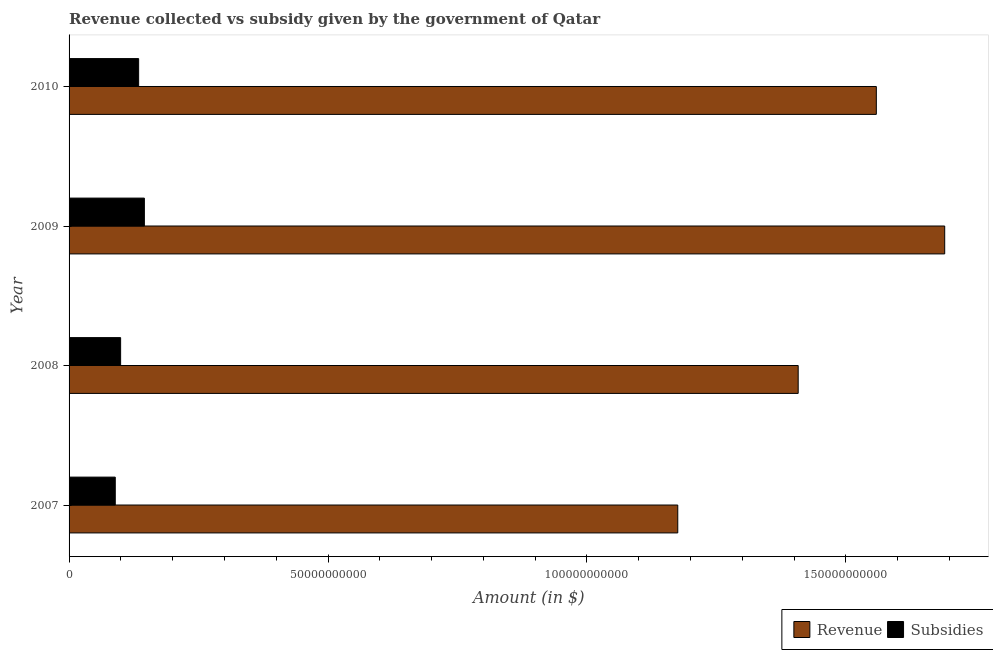How many groups of bars are there?
Your response must be concise. 4. How many bars are there on the 4th tick from the top?
Make the answer very short. 2. What is the label of the 3rd group of bars from the top?
Make the answer very short. 2008. In how many cases, is the number of bars for a given year not equal to the number of legend labels?
Your answer should be very brief. 0. What is the amount of subsidies given in 2010?
Your answer should be very brief. 1.34e+1. Across all years, what is the maximum amount of subsidies given?
Your response must be concise. 1.45e+1. Across all years, what is the minimum amount of revenue collected?
Keep it short and to the point. 1.18e+11. In which year was the amount of revenue collected maximum?
Provide a succinct answer. 2009. What is the total amount of subsidies given in the graph?
Your answer should be very brief. 4.68e+1. What is the difference between the amount of revenue collected in 2007 and that in 2010?
Your answer should be very brief. -3.83e+1. What is the difference between the amount of subsidies given in 2008 and the amount of revenue collected in 2009?
Give a very brief answer. -1.59e+11. What is the average amount of revenue collected per year?
Offer a very short reply. 1.46e+11. In the year 2009, what is the difference between the amount of revenue collected and amount of subsidies given?
Ensure brevity in your answer.  1.55e+11. What is the ratio of the amount of revenue collected in 2007 to that in 2008?
Provide a short and direct response. 0.83. What is the difference between the highest and the second highest amount of subsidies given?
Make the answer very short. 1.11e+09. What is the difference between the highest and the lowest amount of revenue collected?
Ensure brevity in your answer.  5.15e+1. In how many years, is the amount of revenue collected greater than the average amount of revenue collected taken over all years?
Give a very brief answer. 2. What does the 1st bar from the top in 2010 represents?
Ensure brevity in your answer.  Subsidies. What does the 2nd bar from the bottom in 2007 represents?
Make the answer very short. Subsidies. How many years are there in the graph?
Your answer should be very brief. 4. Does the graph contain grids?
Make the answer very short. No. Where does the legend appear in the graph?
Make the answer very short. Bottom right. How are the legend labels stacked?
Ensure brevity in your answer.  Horizontal. What is the title of the graph?
Ensure brevity in your answer.  Revenue collected vs subsidy given by the government of Qatar. Does "Nonresident" appear as one of the legend labels in the graph?
Offer a very short reply. No. What is the label or title of the X-axis?
Provide a succinct answer. Amount (in $). What is the Amount (in $) in Revenue in 2007?
Your response must be concise. 1.18e+11. What is the Amount (in $) of Subsidies in 2007?
Give a very brief answer. 8.92e+09. What is the Amount (in $) in Revenue in 2008?
Give a very brief answer. 1.41e+11. What is the Amount (in $) of Subsidies in 2008?
Your answer should be compact. 9.95e+09. What is the Amount (in $) in Revenue in 2009?
Give a very brief answer. 1.69e+11. What is the Amount (in $) in Subsidies in 2009?
Your answer should be compact. 1.45e+1. What is the Amount (in $) in Revenue in 2010?
Your answer should be very brief. 1.56e+11. What is the Amount (in $) of Subsidies in 2010?
Offer a very short reply. 1.34e+1. Across all years, what is the maximum Amount (in $) of Revenue?
Give a very brief answer. 1.69e+11. Across all years, what is the maximum Amount (in $) of Subsidies?
Your answer should be very brief. 1.45e+1. Across all years, what is the minimum Amount (in $) of Revenue?
Keep it short and to the point. 1.18e+11. Across all years, what is the minimum Amount (in $) in Subsidies?
Keep it short and to the point. 8.92e+09. What is the total Amount (in $) in Revenue in the graph?
Provide a short and direct response. 5.83e+11. What is the total Amount (in $) in Subsidies in the graph?
Provide a succinct answer. 4.68e+1. What is the difference between the Amount (in $) of Revenue in 2007 and that in 2008?
Your response must be concise. -2.33e+1. What is the difference between the Amount (in $) of Subsidies in 2007 and that in 2008?
Provide a short and direct response. -1.03e+09. What is the difference between the Amount (in $) of Revenue in 2007 and that in 2009?
Keep it short and to the point. -5.15e+1. What is the difference between the Amount (in $) of Subsidies in 2007 and that in 2009?
Provide a succinct answer. -5.62e+09. What is the difference between the Amount (in $) in Revenue in 2007 and that in 2010?
Provide a short and direct response. -3.83e+1. What is the difference between the Amount (in $) of Subsidies in 2007 and that in 2010?
Keep it short and to the point. -4.51e+09. What is the difference between the Amount (in $) in Revenue in 2008 and that in 2009?
Provide a short and direct response. -2.83e+1. What is the difference between the Amount (in $) of Subsidies in 2008 and that in 2009?
Provide a short and direct response. -4.59e+09. What is the difference between the Amount (in $) in Revenue in 2008 and that in 2010?
Offer a very short reply. -1.51e+1. What is the difference between the Amount (in $) of Subsidies in 2008 and that in 2010?
Your answer should be very brief. -3.48e+09. What is the difference between the Amount (in $) in Revenue in 2009 and that in 2010?
Provide a short and direct response. 1.32e+1. What is the difference between the Amount (in $) of Subsidies in 2009 and that in 2010?
Your answer should be compact. 1.11e+09. What is the difference between the Amount (in $) in Revenue in 2007 and the Amount (in $) in Subsidies in 2008?
Your response must be concise. 1.08e+11. What is the difference between the Amount (in $) in Revenue in 2007 and the Amount (in $) in Subsidies in 2009?
Offer a very short reply. 1.03e+11. What is the difference between the Amount (in $) of Revenue in 2007 and the Amount (in $) of Subsidies in 2010?
Give a very brief answer. 1.04e+11. What is the difference between the Amount (in $) in Revenue in 2008 and the Amount (in $) in Subsidies in 2009?
Your answer should be compact. 1.26e+11. What is the difference between the Amount (in $) in Revenue in 2008 and the Amount (in $) in Subsidies in 2010?
Your answer should be very brief. 1.27e+11. What is the difference between the Amount (in $) in Revenue in 2009 and the Amount (in $) in Subsidies in 2010?
Ensure brevity in your answer.  1.56e+11. What is the average Amount (in $) of Revenue per year?
Offer a very short reply. 1.46e+11. What is the average Amount (in $) in Subsidies per year?
Keep it short and to the point. 1.17e+1. In the year 2007, what is the difference between the Amount (in $) of Revenue and Amount (in $) of Subsidies?
Ensure brevity in your answer.  1.09e+11. In the year 2008, what is the difference between the Amount (in $) of Revenue and Amount (in $) of Subsidies?
Your answer should be very brief. 1.31e+11. In the year 2009, what is the difference between the Amount (in $) of Revenue and Amount (in $) of Subsidies?
Ensure brevity in your answer.  1.55e+11. In the year 2010, what is the difference between the Amount (in $) in Revenue and Amount (in $) in Subsidies?
Keep it short and to the point. 1.42e+11. What is the ratio of the Amount (in $) of Revenue in 2007 to that in 2008?
Offer a very short reply. 0.83. What is the ratio of the Amount (in $) in Subsidies in 2007 to that in 2008?
Offer a very short reply. 0.9. What is the ratio of the Amount (in $) in Revenue in 2007 to that in 2009?
Offer a very short reply. 0.7. What is the ratio of the Amount (in $) of Subsidies in 2007 to that in 2009?
Your answer should be very brief. 0.61. What is the ratio of the Amount (in $) of Revenue in 2007 to that in 2010?
Keep it short and to the point. 0.75. What is the ratio of the Amount (in $) of Subsidies in 2007 to that in 2010?
Provide a short and direct response. 0.66. What is the ratio of the Amount (in $) of Revenue in 2008 to that in 2009?
Provide a short and direct response. 0.83. What is the ratio of the Amount (in $) in Subsidies in 2008 to that in 2009?
Make the answer very short. 0.68. What is the ratio of the Amount (in $) in Revenue in 2008 to that in 2010?
Offer a very short reply. 0.9. What is the ratio of the Amount (in $) in Subsidies in 2008 to that in 2010?
Make the answer very short. 0.74. What is the ratio of the Amount (in $) in Revenue in 2009 to that in 2010?
Provide a short and direct response. 1.08. What is the ratio of the Amount (in $) of Subsidies in 2009 to that in 2010?
Give a very brief answer. 1.08. What is the difference between the highest and the second highest Amount (in $) of Revenue?
Make the answer very short. 1.32e+1. What is the difference between the highest and the second highest Amount (in $) in Subsidies?
Your response must be concise. 1.11e+09. What is the difference between the highest and the lowest Amount (in $) of Revenue?
Make the answer very short. 5.15e+1. What is the difference between the highest and the lowest Amount (in $) in Subsidies?
Your answer should be very brief. 5.62e+09. 